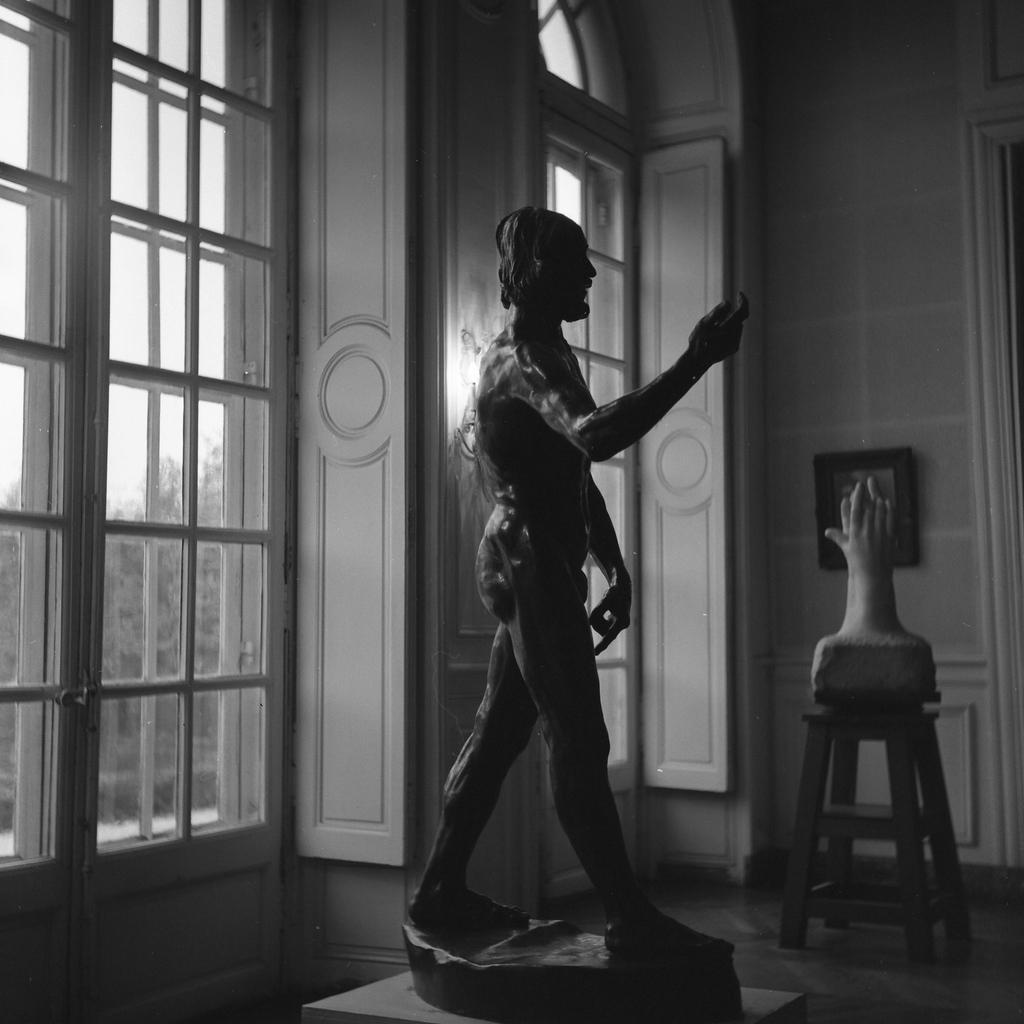How would you summarize this image in a sentence or two? This image consist of a statue which is in the center. On the left side there is a door and in the center there is a statue on the stool. On the wall there is a frame. Outside of the door there are trees and the sky is cloudy. 